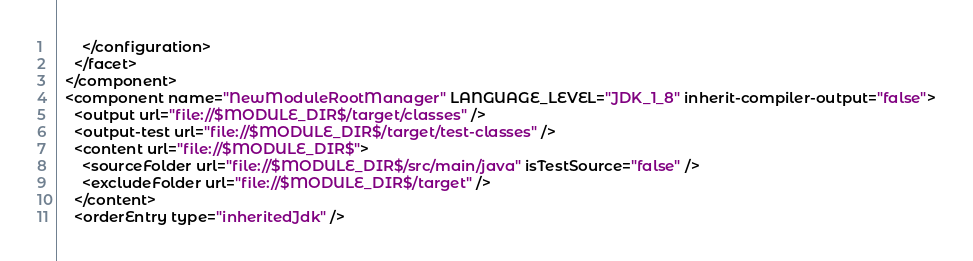<code> <loc_0><loc_0><loc_500><loc_500><_XML_>      </configuration>
    </facet>
  </component>
  <component name="NewModuleRootManager" LANGUAGE_LEVEL="JDK_1_8" inherit-compiler-output="false">
    <output url="file://$MODULE_DIR$/target/classes" />
    <output-test url="file://$MODULE_DIR$/target/test-classes" />
    <content url="file://$MODULE_DIR$">
      <sourceFolder url="file://$MODULE_DIR$/src/main/java" isTestSource="false" />
      <excludeFolder url="file://$MODULE_DIR$/target" />
    </content>
    <orderEntry type="inheritedJdk" /></code> 